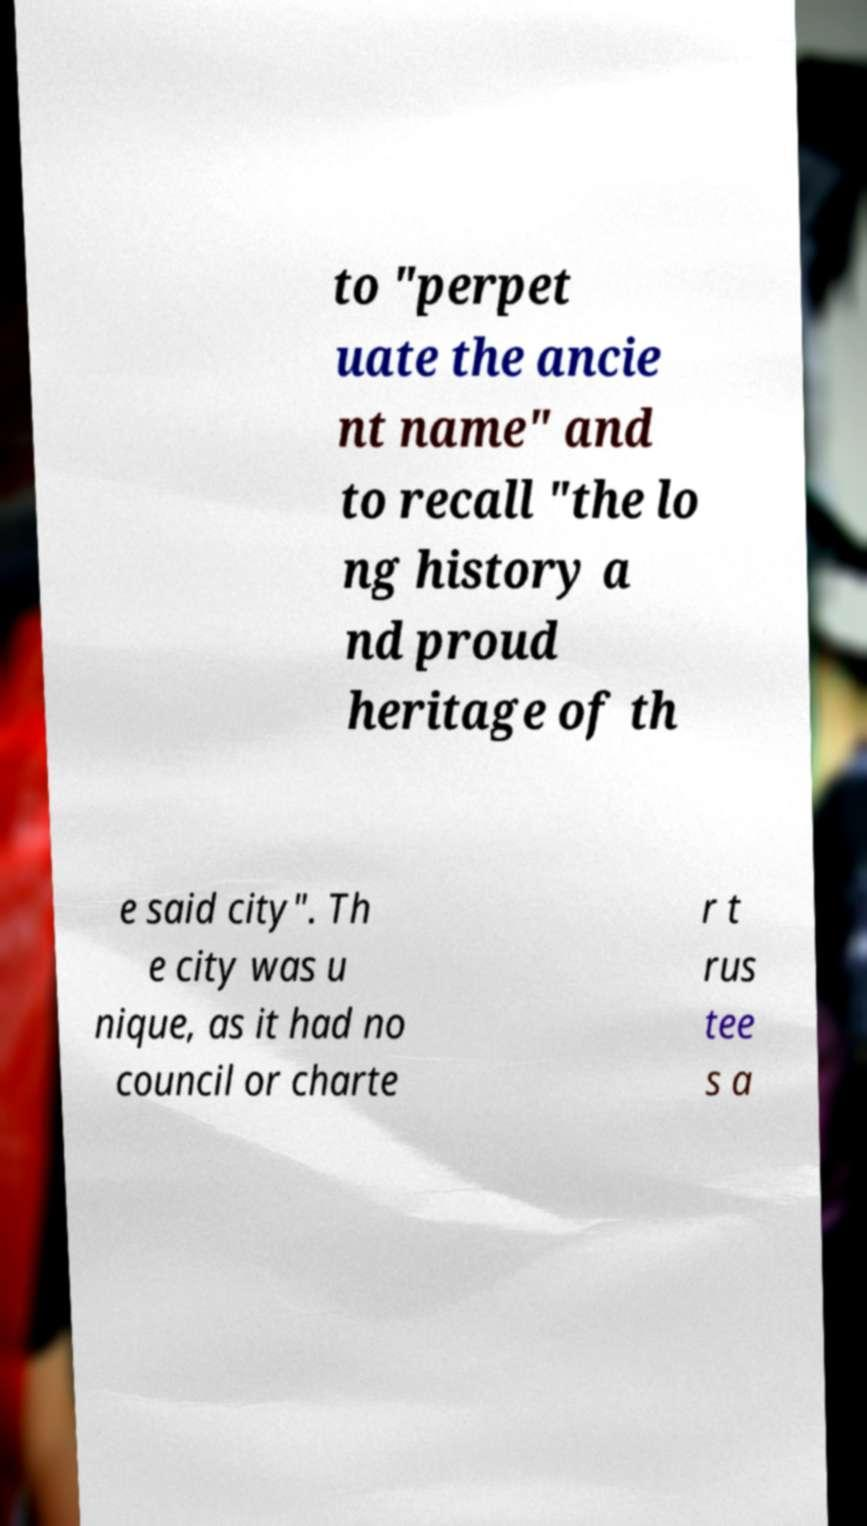I need the written content from this picture converted into text. Can you do that? to "perpet uate the ancie nt name" and to recall "the lo ng history a nd proud heritage of th e said city". Th e city was u nique, as it had no council or charte r t rus tee s a 